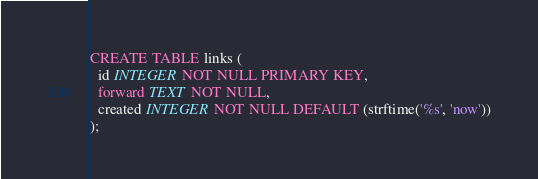Convert code to text. <code><loc_0><loc_0><loc_500><loc_500><_SQL_>CREATE TABLE links (
  id INTEGER NOT NULL PRIMARY KEY,
  forward TEXT NOT NULL,
  created INTEGER NOT NULL DEFAULT (strftime('%s', 'now'))
);
</code> 